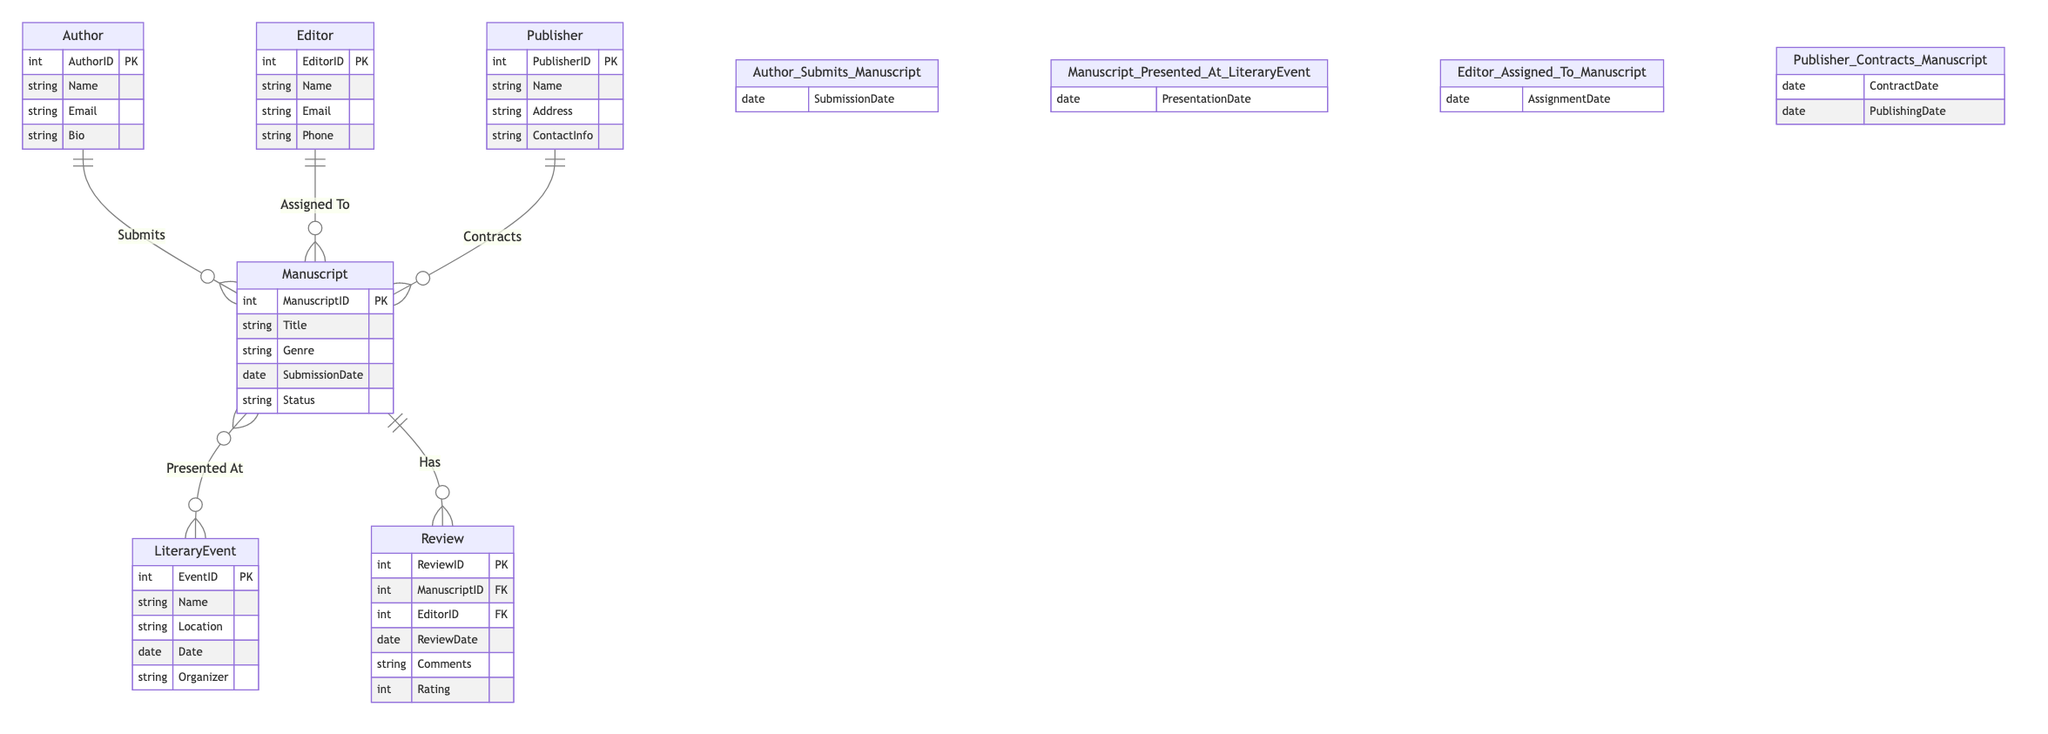What entities are involved in the manuscript review process? The entities involved in the manuscript review process are Manuscript and Review, as indicated by the "Has" relationship between them.
Answer: Manuscript, Review How many attributes does the Author entity have? The Author entity has four attributes: AuthorID, Name, Email, and Bio.
Answer: Four What is the relationship between Manuscript and LiteraryEvent? The relationship is "Presented At," which indicates that manuscripts are presented at literary events.
Answer: Presented At How many different entities are shown in the diagram? There are six entities shown in the diagram: Author, Manuscript, LiteraryEvent, Publisher, Editor, and Review.
Answer: Six Which entity is associated with the contract date and publishing date for manuscripts? The entity associated with the contract date and publishing date is Publisher, as it has a relationship named "Contracts" with Manuscript that includes those attributes.
Answer: Publisher What additional information is provided in the relationship between Author and Manuscript? The relationship between Author and Manuscript provides the submission date as additional information.
Answer: SubmissionDate What is the maximum number of reviews a manuscript can have according to the diagram? Since there is a "Has" relationship indicating Manuscript can have multiple Reviews, the maximum number is potentially many, but this is not defined in the diagram explicitly.
Answer: Many What attributes are reported under the Editort entity? The Editor entity has four attributes: EditorID, Name, Email, and Phone.
Answer: Four What does the review contain for each manuscript? Each review contains the review date, comments, and rating, which can be deduced from the attributes listed under the Review entity.
Answer: ReviewDate, Comments, Rating 